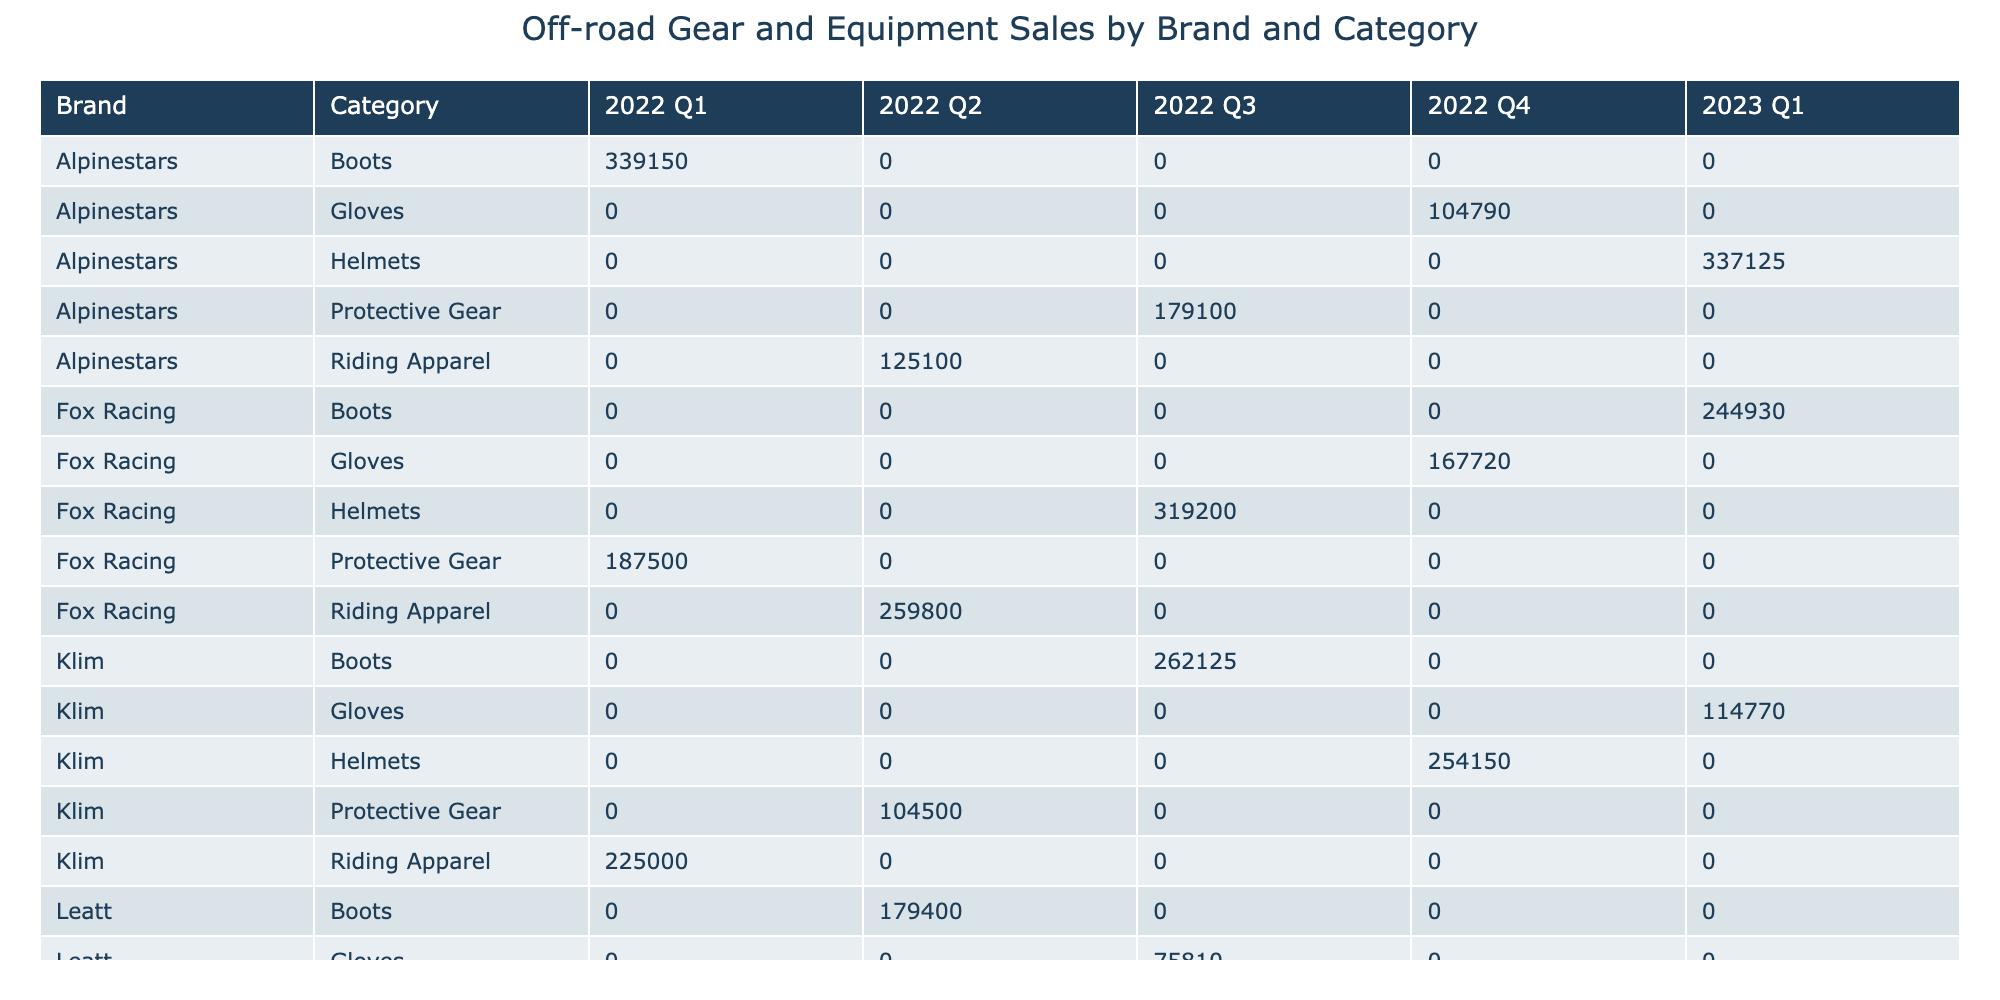What is the total revenue for Fox Racing in 2022? To find this, I will look for all entries related to Fox Racing in 2022. The revenues for Fox Racing in Q1, Q2, Q3, and Q4 are 187500, 259800, 319200, and 167720 respectively. Summing these values gives: 187500 + 259800 + 319200 + 167720 = 934220.
Answer: 934220 Which brand had the highest sales revenue in Q3 of 2022? I will check the revenues of all brands specifically in Q3 of 2022. The revenues are Fox Racing at 319200, Troy Lee Designs at 219780, Klim at 262125, Alpinestars at 179100, Leatt at 75810, and O'Neal at 119760. The highest value is 319200 from Fox Racing.
Answer: Fox Racing What is the average revenue for Troy Lee Designs across all quarters in 2022? I will first gather the revenues for Troy Lee Designs across each quarter: Q1 is 245000, Q2 is 124750, Q3 is 219780, and Q4 is 101660. Summing these gives: 245000 + 124750 + 219780 + 101660 = 691190. Then, I divide by 4 (the number of quarters) to find the average: 691190 / 4 = 172797.5.
Answer: 172797.5 Is there any revenue recorded for Leatt in Q4 2023? To answer this, I will check the entry for Leatt in Q4 2023. There are no entries for Leatt in the provided data for Q4 2023, indicating that there were no recorded sales or revenue.
Answer: No What was the total units sold for Alpinestars across all quarters in 2022? I will list the units sold for Alpinestars in each quarter: Q1 is 850, Q2 is 1800, Q3 is 900, and Q4 is 2100. Summing these gives: 850 + 1800 + 900 + 2100 = 4650 units sold in total.
Answer: 4650 